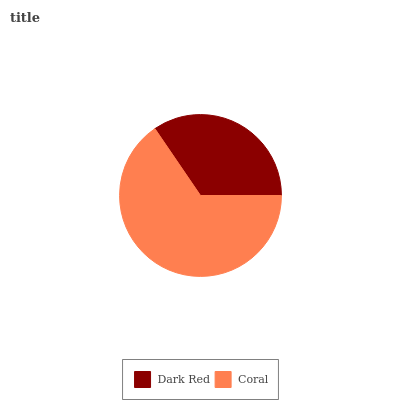Is Dark Red the minimum?
Answer yes or no. Yes. Is Coral the maximum?
Answer yes or no. Yes. Is Coral the minimum?
Answer yes or no. No. Is Coral greater than Dark Red?
Answer yes or no. Yes. Is Dark Red less than Coral?
Answer yes or no. Yes. Is Dark Red greater than Coral?
Answer yes or no. No. Is Coral less than Dark Red?
Answer yes or no. No. Is Coral the high median?
Answer yes or no. Yes. Is Dark Red the low median?
Answer yes or no. Yes. Is Dark Red the high median?
Answer yes or no. No. Is Coral the low median?
Answer yes or no. No. 